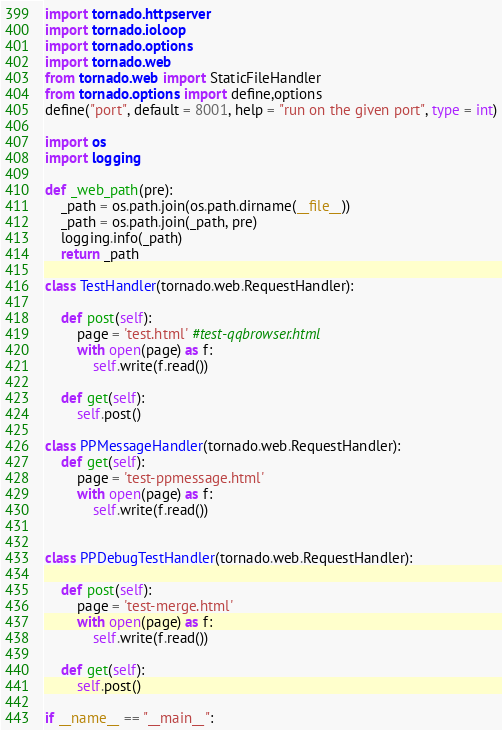Convert code to text. <code><loc_0><loc_0><loc_500><loc_500><_Python_>import tornado.httpserver
import tornado.ioloop
import tornado.options
import tornado.web
from tornado.web import StaticFileHandler
from tornado.options import define,options
define("port", default = 8001, help = "run on the given port", type = int)

import os
import logging

def _web_path(pre):
    _path = os.path.join(os.path.dirname(__file__))
    _path = os.path.join(_path, pre)
    logging.info(_path)
    return _path

class TestHandler(tornado.web.RequestHandler):
    
    def post(self):
        page = 'test.html' #test-qqbrowser.html
        with open(page) as f:
            self.write(f.read())

    def get(self):
        self.post()

class PPMessageHandler(tornado.web.RequestHandler):
    def get(self):
        page = 'test-ppmessage.html'
        with open(page) as f:
            self.write(f.read())


class PPDebugTestHandler(tornado.web.RequestHandler):
    
    def post(self):
        page = 'test-merge.html'
        with open(page) as f:
            self.write(f.read())

    def get(self):
        self.post()

if __name__ == "__main__":</code> 